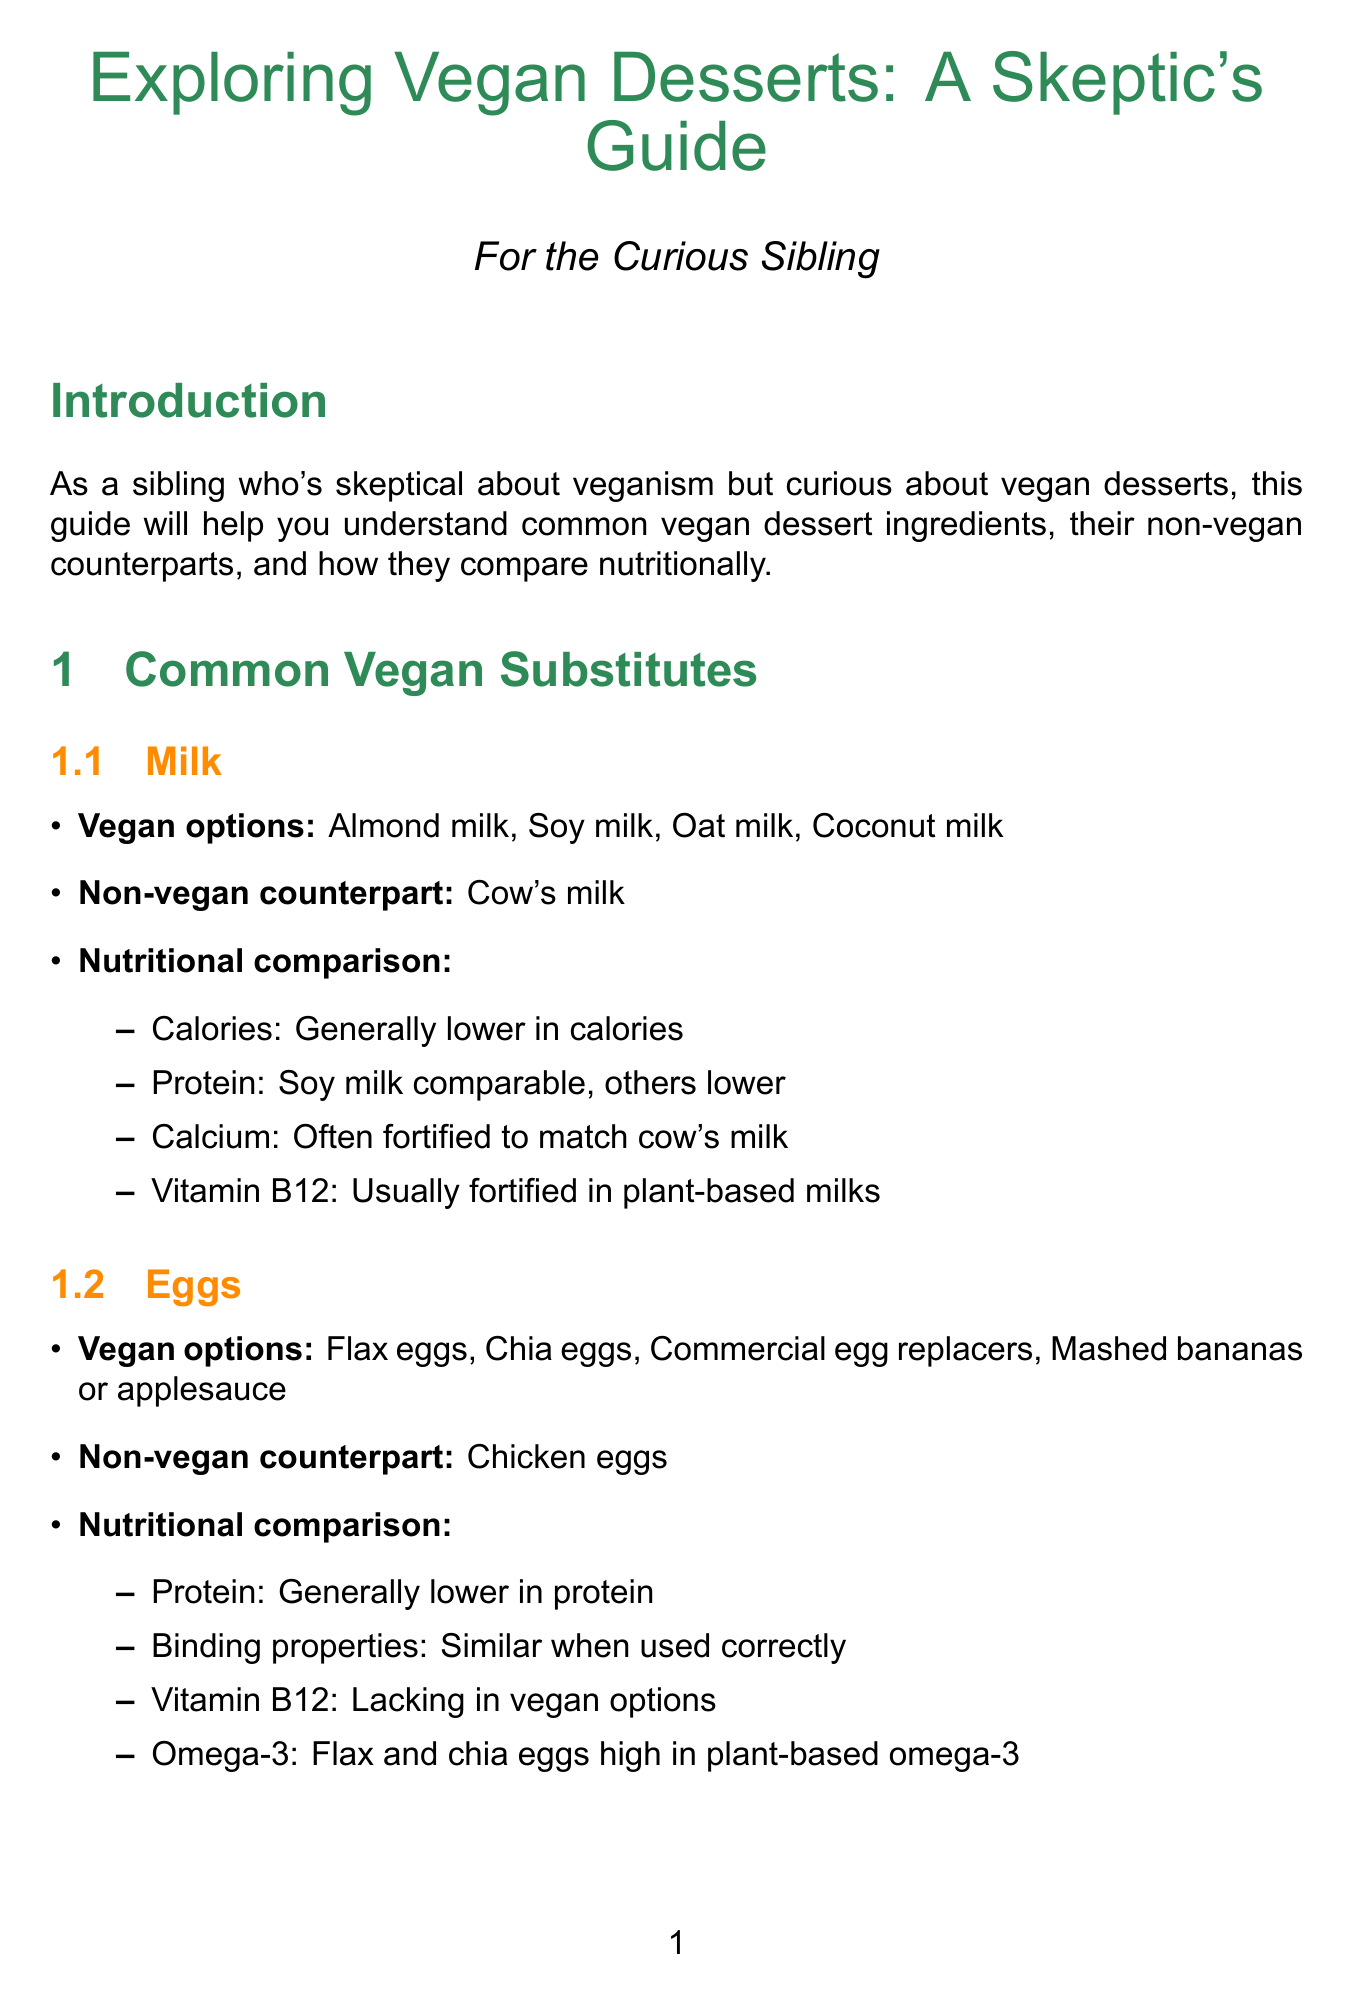What are some vegan options for milk? The section on milk lists vegan options, including almond milk, soy milk, oat milk, and coconut milk.
Answer: Almond milk, soy milk, oat milk, coconut milk What is the non-vegan counterpart to eggs? The document states that the non-vegan counterpart to eggs is chicken eggs.
Answer: Chicken eggs Which vegan butter substitute is noted for being cholesterol-free? The section on butter mentions that vegan options are cholesterol-free; one example is vegan margarine.
Answer: Vegan margarine What is the glycemic index of coconut sugar compared to refined sugar? It states that coconut sugar has a lower glycemic index than refined sugar.
Answer: Lower GI Which sweetener is high in antioxidants according to the document? The section on honey indicates that maple syrup is high in antioxidants.
Answer: Maple syrup What are two vegan options for gelatin alternatives mentioned? The document lists agar-agar and carrageenan as vegan alternatives to gelatin.
Answer: Agar-agar, carrageenan What does the conclusion encourage skeptical individuals to do? The conclusion encourages readers to try vegan desserts and see how they compare to traditional ones.
Answer: Try vegan desserts What is one nutritional benefit of vegan chocolate compared to milk chocolate? The document states that vegan options often have lower sugar content compared to milk chocolate.
Answer: Lower sugar content 